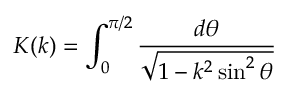<formula> <loc_0><loc_0><loc_500><loc_500>K ( k ) = \int _ { 0 } ^ { \pi / 2 } \frac { d \theta } { \sqrt { 1 - k ^ { 2 } \sin ^ { 2 } \theta } }</formula> 